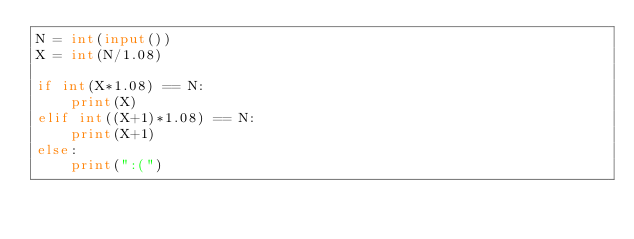Convert code to text. <code><loc_0><loc_0><loc_500><loc_500><_Python_>N = int(input())
X = int(N/1.08)

if int(X*1.08) == N:
    print(X)
elif int((X+1)*1.08) == N:
    print(X+1)
else:
    print(":(")
</code> 